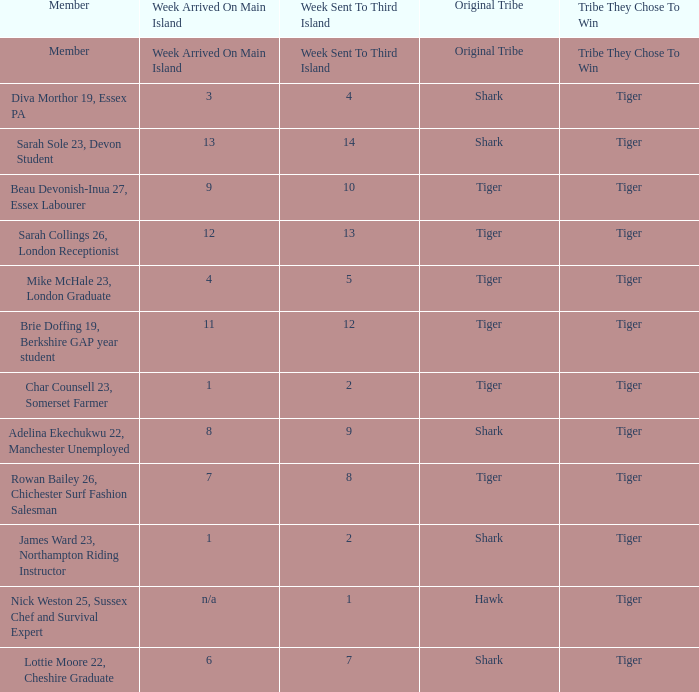What week was the member who arrived on the main island in week 6 sent to the third island? 7.0. 